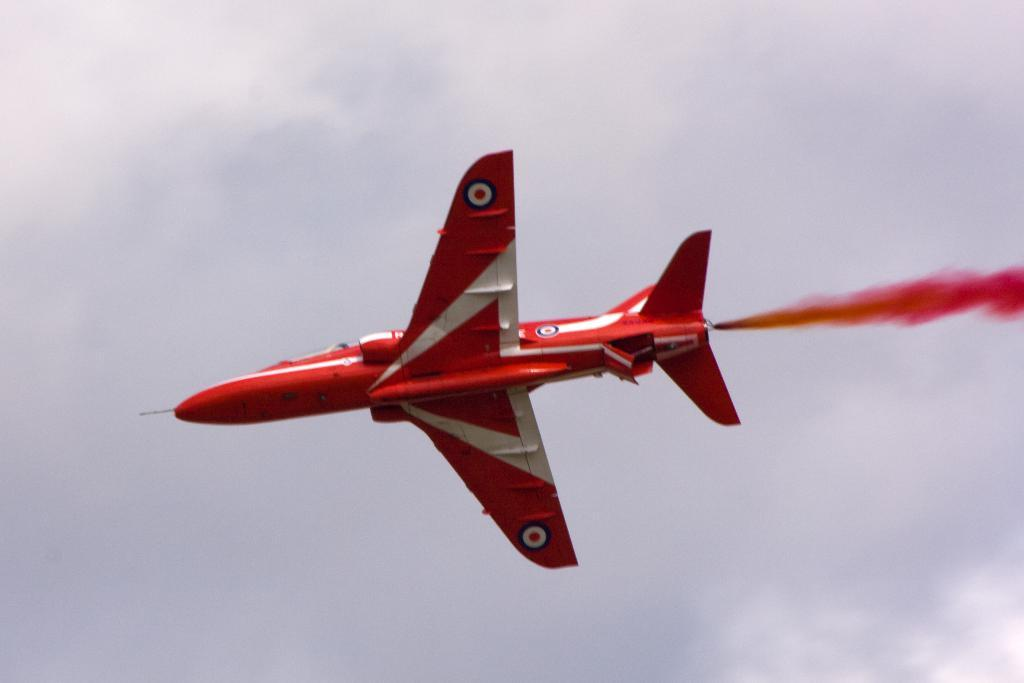What is the main subject of the image? The main subject of the image is an airplane. What is the airplane doing in the image? The airplane is flying in the image. What can be seen in the background of the image? The sky is visible in the background of the image. What type of game is being played in the image? There is no game being played in the image; it features an airplane flying in the sky. What subject is being learned in the image? There is no learning activity depicted in the image; it simply shows an airplane flying. 